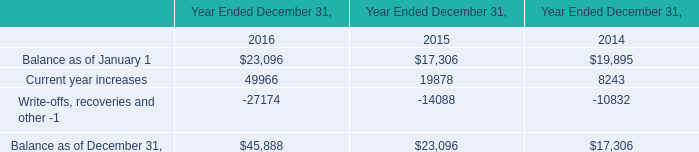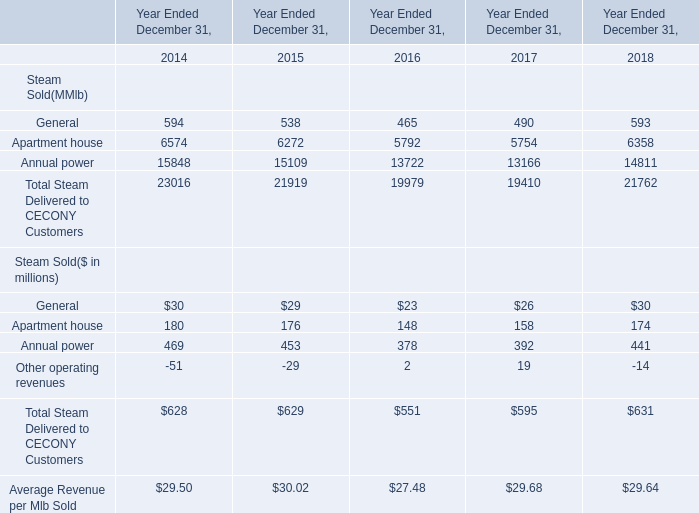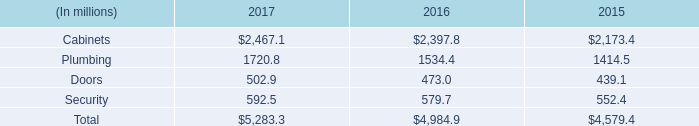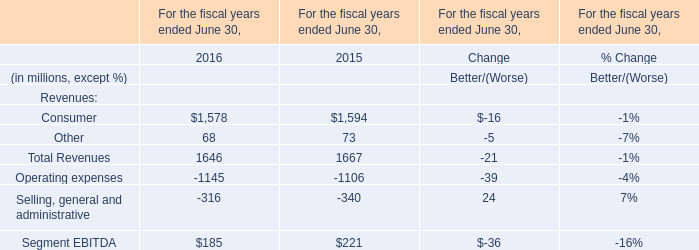What is the growing rate of Generalin the year with the most Steam Delivered to CECONY Customers? 
Computations: ((30 - 29) / 29)
Answer: 0.03448. 